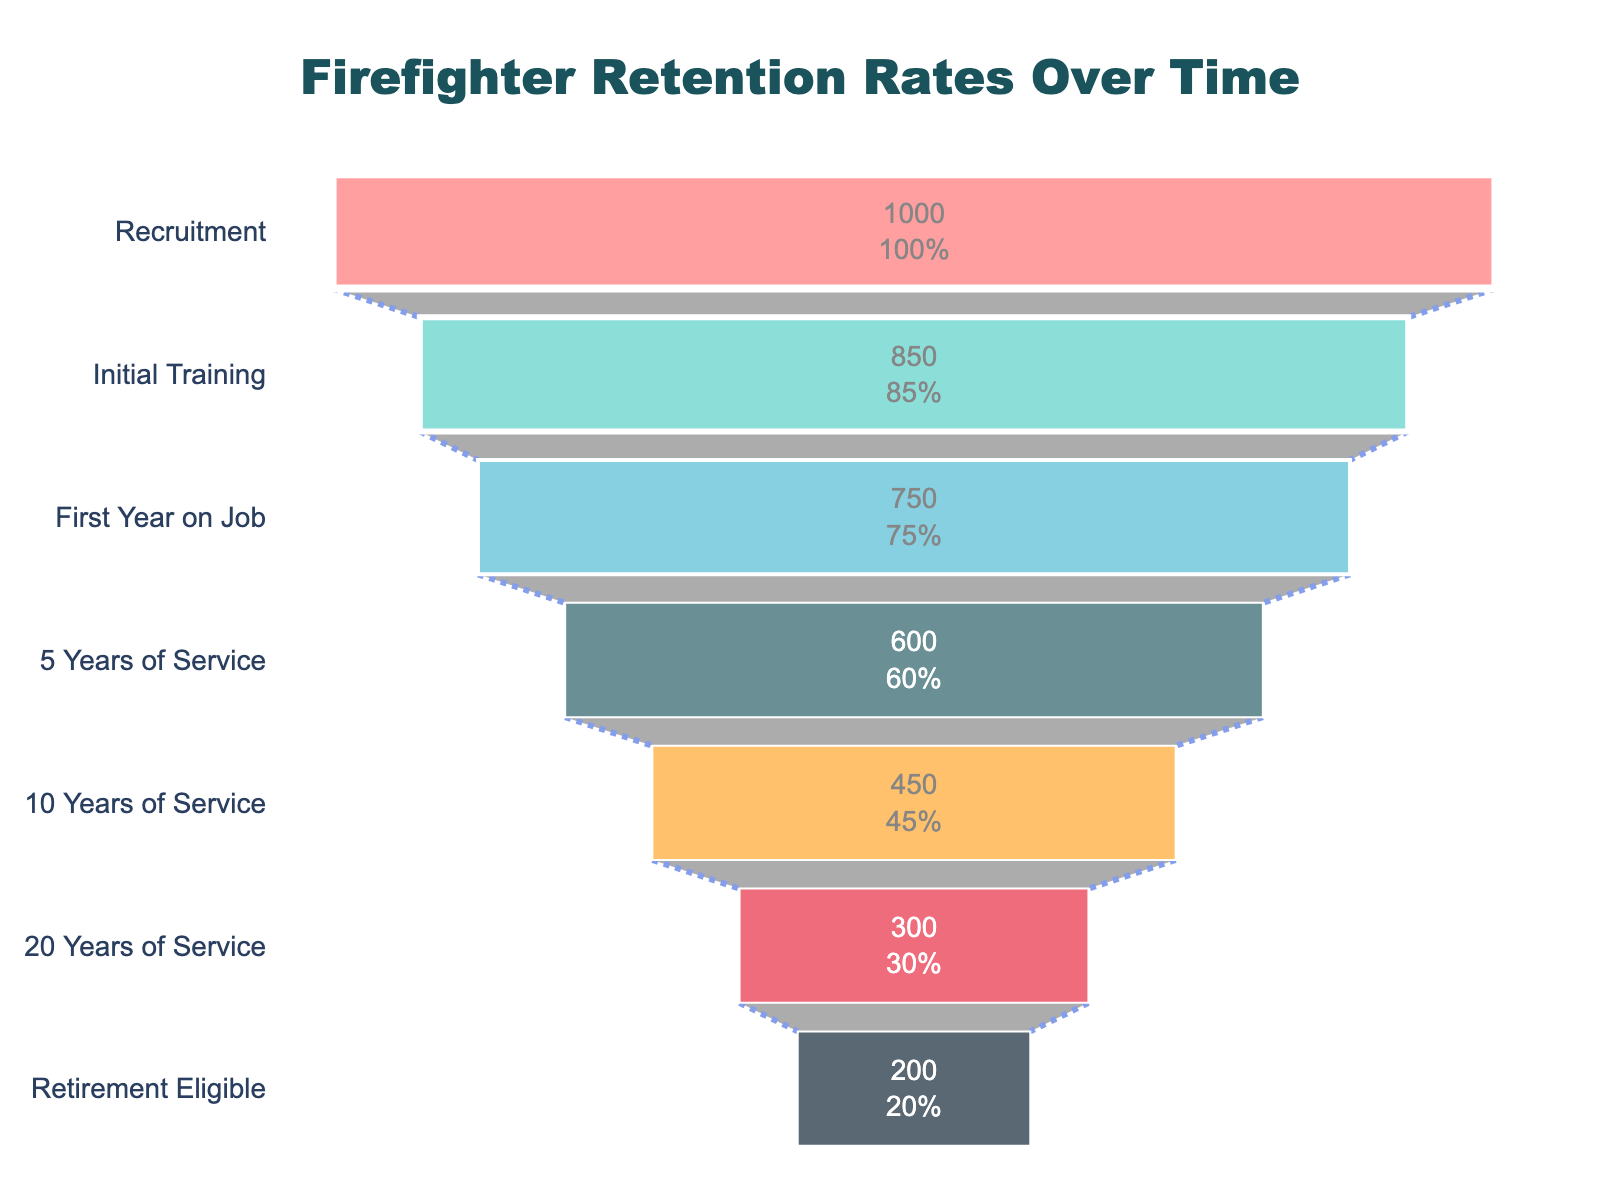How many stages are shown in the funnel chart? The funnel chart lists the stages from recruitment to retirement. Counting each stage mentioned in the data set: Recruitment, Initial Training, First Year on Job, 5 Years of Service, 10 Years of Service, 20 Years of Service, and Retirement Eligible, gives a total of 7 stages.
Answer: 7 What percentage of firefighters remains after the first year on the job? Referring to the figure, at the stage of "First Year on Job," the percentage shows 75%.
Answer: 75% How much does the number of firefighters decrease from recruitment to initial training? Comparing recruitment and initial training stages, initial training has 850 firefighters and recruitment has 1000. The decrease can be calculated as 1000 - 850 = 150.
Answer: 150 Which stage sees the largest drop in the number of firefighters? By examining the differences between consecutive stages, the largest drop occurs from "10 Years of Service" (450) to "20 Years of Service" (300) with a decrease of 450 - 300 = 150.
Answer: 10 Years of Service to 20 Years of Service What is the total number of firefighters that remain after 10 years of service? The value shown for the "10 Years of Service" stage indicates the remaining number of firefighters, which is 450.
Answer: 450 Which stage marks the halfway point in terms of the percentage of firefighters remaining? The "5 Years of Service" stage shows 60%, which is closest to half of the initial 100%.
Answer: 5 Years of Service What is the difference in percentage points between the stages of 5 years of service and retirement eligibility? The percentage for "5 Years of Service" is 60% and for "Retirement Eligible" it's 20%. The difference can be calculated as 60% - 20% = 40%.
Answer: 40% Compare the retention rate between the first year on the job and 10 years of service. The first year on the job has a retention rate of 75%, whereas 10 years of service has 45%. The difference in retention rates is 75% - 45% = 30%.
Answer: 30% How many firefighters remain after 20 years of service, assuming the initial recruitment had 1000 firefighters? From the data, after 20 years of service, the number of firefighters remaining is 300.
Answer: 300 What stage immediately follows 'First Year on Job' in the funnel chart? The stage immediately following 'First Year on Job' is '5 Years of Service,' based on the sequence in the funnel chart.
Answer: 5 Years of Service 